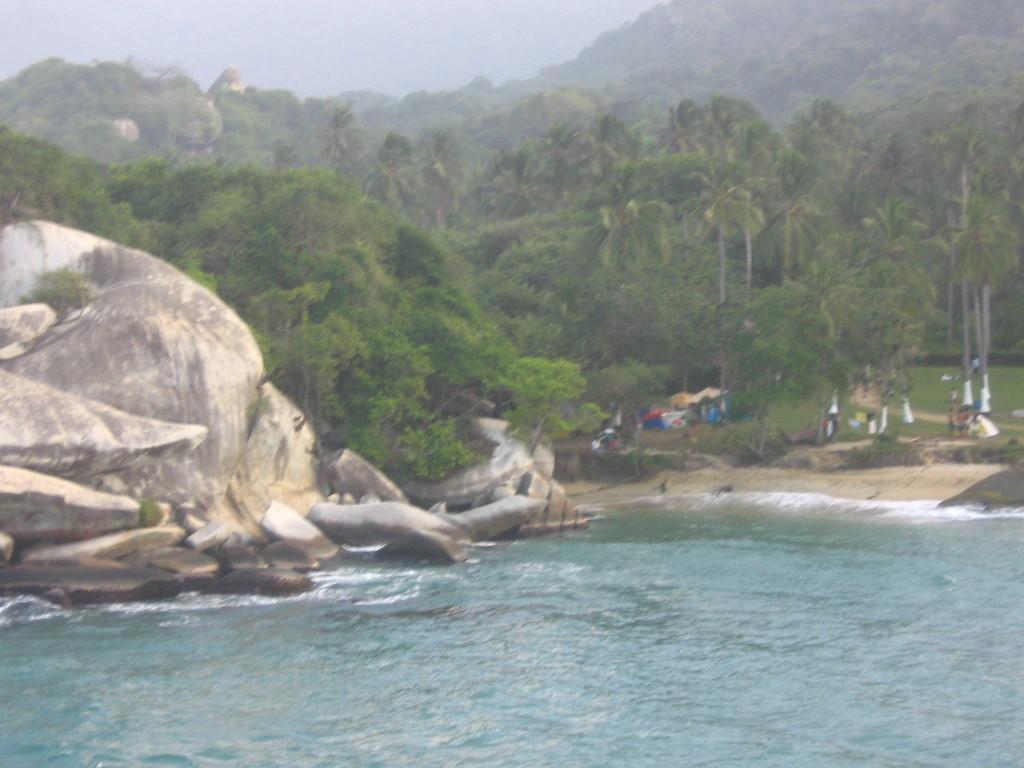Could you give a brief overview of what you see in this image? We can see water, rocks and trees. In the background we can see people, grass, tents, trees and sky. 